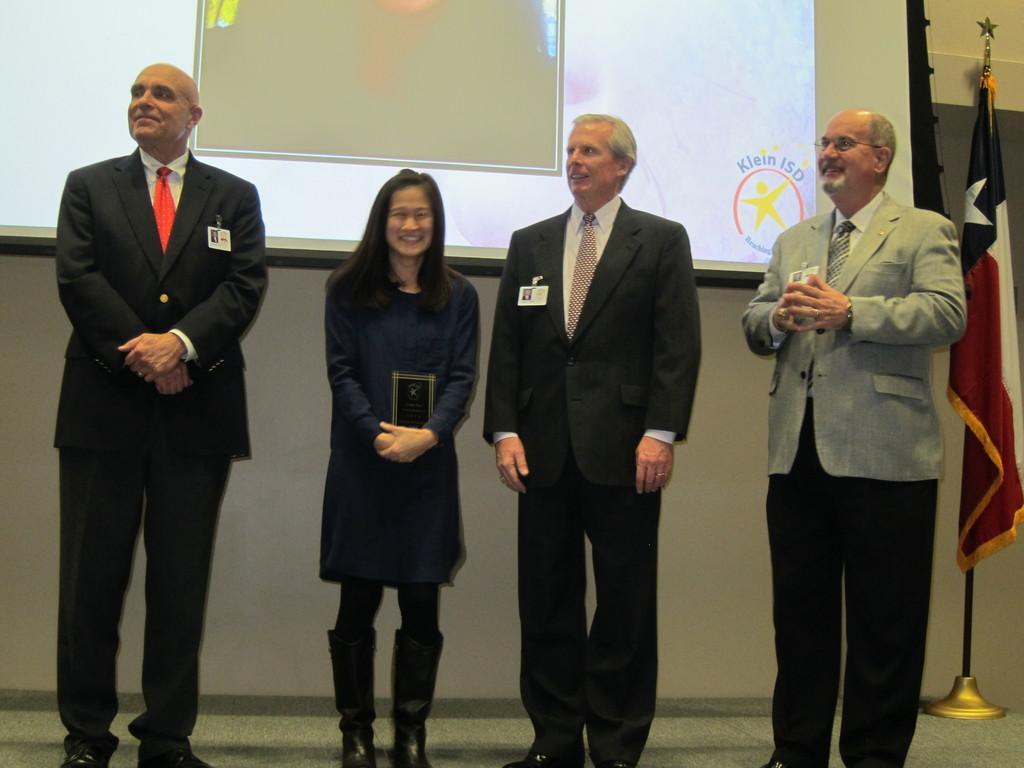How would you summarize this image in a sentence or two? In this image we can see a group of people standing. There is a projector screen in the image. There is a flag at the left side of the image. A lady is holding an object in her hands and few people are wearing identity cards in the image. 